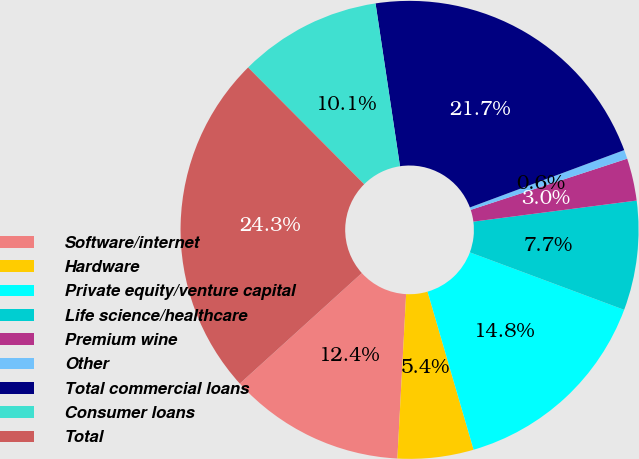Convert chart to OTSL. <chart><loc_0><loc_0><loc_500><loc_500><pie_chart><fcel>Software/internet<fcel>Hardware<fcel>Private equity/venture capital<fcel>Life science/healthcare<fcel>Premium wine<fcel>Other<fcel>Total commercial loans<fcel>Consumer loans<fcel>Total<nl><fcel>12.44%<fcel>5.36%<fcel>14.81%<fcel>7.72%<fcel>2.99%<fcel>0.63%<fcel>21.71%<fcel>10.08%<fcel>24.26%<nl></chart> 